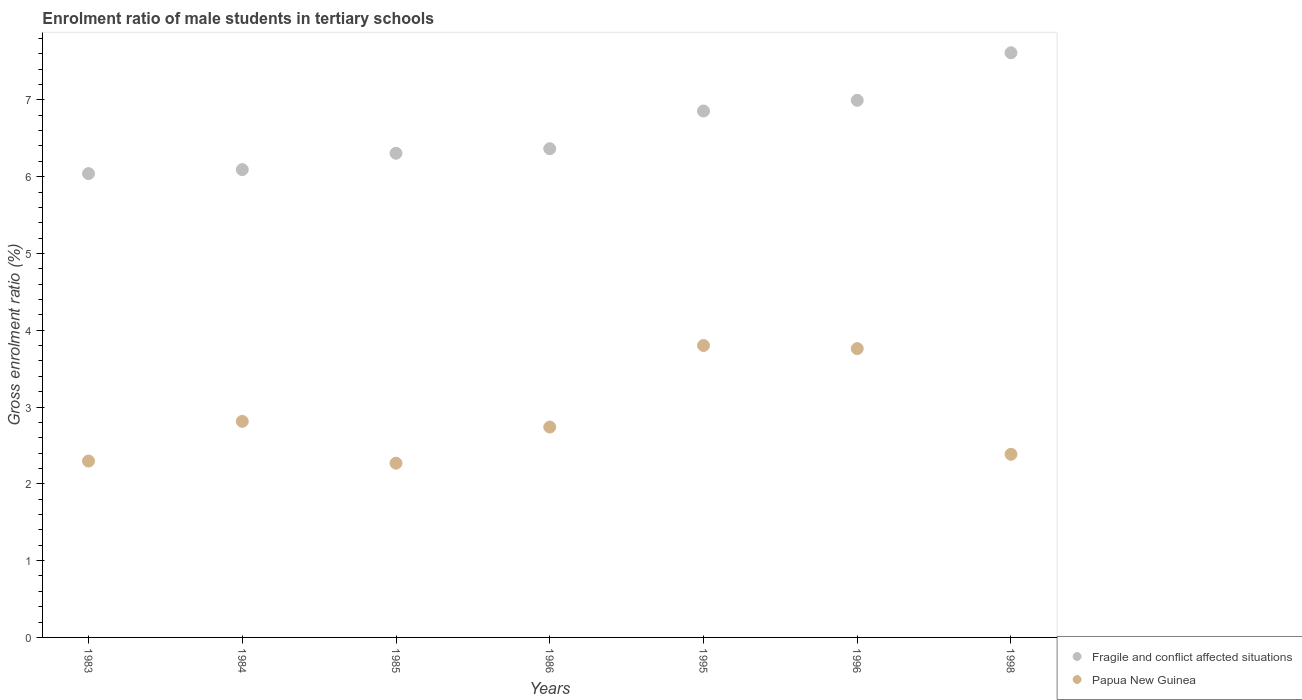How many different coloured dotlines are there?
Provide a succinct answer. 2. What is the enrolment ratio of male students in tertiary schools in Papua New Guinea in 1985?
Offer a very short reply. 2.27. Across all years, what is the maximum enrolment ratio of male students in tertiary schools in Papua New Guinea?
Keep it short and to the point. 3.8. Across all years, what is the minimum enrolment ratio of male students in tertiary schools in Papua New Guinea?
Your answer should be compact. 2.27. In which year was the enrolment ratio of male students in tertiary schools in Fragile and conflict affected situations maximum?
Ensure brevity in your answer.  1998. What is the total enrolment ratio of male students in tertiary schools in Papua New Guinea in the graph?
Make the answer very short. 20.07. What is the difference between the enrolment ratio of male students in tertiary schools in Papua New Guinea in 1983 and that in 1998?
Make the answer very short. -0.09. What is the difference between the enrolment ratio of male students in tertiary schools in Papua New Guinea in 1998 and the enrolment ratio of male students in tertiary schools in Fragile and conflict affected situations in 1986?
Offer a terse response. -3.98. What is the average enrolment ratio of male students in tertiary schools in Fragile and conflict affected situations per year?
Ensure brevity in your answer.  6.61. In the year 1998, what is the difference between the enrolment ratio of male students in tertiary schools in Fragile and conflict affected situations and enrolment ratio of male students in tertiary schools in Papua New Guinea?
Your answer should be very brief. 5.23. In how many years, is the enrolment ratio of male students in tertiary schools in Fragile and conflict affected situations greater than 6.8 %?
Your answer should be compact. 3. What is the ratio of the enrolment ratio of male students in tertiary schools in Papua New Guinea in 1983 to that in 1986?
Make the answer very short. 0.84. Is the enrolment ratio of male students in tertiary schools in Fragile and conflict affected situations in 1985 less than that in 1998?
Provide a short and direct response. Yes. What is the difference between the highest and the second highest enrolment ratio of male students in tertiary schools in Papua New Guinea?
Offer a very short reply. 0.04. What is the difference between the highest and the lowest enrolment ratio of male students in tertiary schools in Papua New Guinea?
Make the answer very short. 1.53. In how many years, is the enrolment ratio of male students in tertiary schools in Fragile and conflict affected situations greater than the average enrolment ratio of male students in tertiary schools in Fragile and conflict affected situations taken over all years?
Make the answer very short. 3. Is the sum of the enrolment ratio of male students in tertiary schools in Papua New Guinea in 1984 and 1995 greater than the maximum enrolment ratio of male students in tertiary schools in Fragile and conflict affected situations across all years?
Offer a very short reply. No. Is the enrolment ratio of male students in tertiary schools in Fragile and conflict affected situations strictly less than the enrolment ratio of male students in tertiary schools in Papua New Guinea over the years?
Keep it short and to the point. No. How many dotlines are there?
Your answer should be very brief. 2. How many years are there in the graph?
Make the answer very short. 7. What is the difference between two consecutive major ticks on the Y-axis?
Provide a short and direct response. 1. Are the values on the major ticks of Y-axis written in scientific E-notation?
Your answer should be compact. No. Does the graph contain grids?
Your response must be concise. No. Where does the legend appear in the graph?
Keep it short and to the point. Bottom right. What is the title of the graph?
Give a very brief answer. Enrolment ratio of male students in tertiary schools. What is the Gross enrolment ratio (%) of Fragile and conflict affected situations in 1983?
Provide a succinct answer. 6.04. What is the Gross enrolment ratio (%) of Papua New Guinea in 1983?
Offer a terse response. 2.3. What is the Gross enrolment ratio (%) of Fragile and conflict affected situations in 1984?
Offer a terse response. 6.09. What is the Gross enrolment ratio (%) in Papua New Guinea in 1984?
Provide a succinct answer. 2.81. What is the Gross enrolment ratio (%) in Fragile and conflict affected situations in 1985?
Ensure brevity in your answer.  6.31. What is the Gross enrolment ratio (%) in Papua New Guinea in 1985?
Your answer should be very brief. 2.27. What is the Gross enrolment ratio (%) in Fragile and conflict affected situations in 1986?
Provide a short and direct response. 6.36. What is the Gross enrolment ratio (%) of Papua New Guinea in 1986?
Your answer should be compact. 2.74. What is the Gross enrolment ratio (%) in Fragile and conflict affected situations in 1995?
Your answer should be very brief. 6.86. What is the Gross enrolment ratio (%) in Papua New Guinea in 1995?
Your response must be concise. 3.8. What is the Gross enrolment ratio (%) of Fragile and conflict affected situations in 1996?
Offer a terse response. 6.99. What is the Gross enrolment ratio (%) of Papua New Guinea in 1996?
Offer a terse response. 3.76. What is the Gross enrolment ratio (%) in Fragile and conflict affected situations in 1998?
Offer a very short reply. 7.61. What is the Gross enrolment ratio (%) in Papua New Guinea in 1998?
Offer a terse response. 2.38. Across all years, what is the maximum Gross enrolment ratio (%) of Fragile and conflict affected situations?
Provide a succinct answer. 7.61. Across all years, what is the maximum Gross enrolment ratio (%) in Papua New Guinea?
Offer a very short reply. 3.8. Across all years, what is the minimum Gross enrolment ratio (%) of Fragile and conflict affected situations?
Ensure brevity in your answer.  6.04. Across all years, what is the minimum Gross enrolment ratio (%) of Papua New Guinea?
Provide a succinct answer. 2.27. What is the total Gross enrolment ratio (%) of Fragile and conflict affected situations in the graph?
Provide a succinct answer. 46.26. What is the total Gross enrolment ratio (%) in Papua New Guinea in the graph?
Your answer should be very brief. 20.07. What is the difference between the Gross enrolment ratio (%) in Fragile and conflict affected situations in 1983 and that in 1984?
Make the answer very short. -0.05. What is the difference between the Gross enrolment ratio (%) of Papua New Guinea in 1983 and that in 1984?
Make the answer very short. -0.52. What is the difference between the Gross enrolment ratio (%) in Fragile and conflict affected situations in 1983 and that in 1985?
Offer a very short reply. -0.27. What is the difference between the Gross enrolment ratio (%) of Papua New Guinea in 1983 and that in 1985?
Make the answer very short. 0.03. What is the difference between the Gross enrolment ratio (%) in Fragile and conflict affected situations in 1983 and that in 1986?
Provide a succinct answer. -0.32. What is the difference between the Gross enrolment ratio (%) in Papua New Guinea in 1983 and that in 1986?
Your response must be concise. -0.44. What is the difference between the Gross enrolment ratio (%) in Fragile and conflict affected situations in 1983 and that in 1995?
Your answer should be compact. -0.82. What is the difference between the Gross enrolment ratio (%) in Papua New Guinea in 1983 and that in 1995?
Offer a terse response. -1.5. What is the difference between the Gross enrolment ratio (%) of Fragile and conflict affected situations in 1983 and that in 1996?
Your answer should be very brief. -0.95. What is the difference between the Gross enrolment ratio (%) in Papua New Guinea in 1983 and that in 1996?
Your response must be concise. -1.46. What is the difference between the Gross enrolment ratio (%) of Fragile and conflict affected situations in 1983 and that in 1998?
Ensure brevity in your answer.  -1.57. What is the difference between the Gross enrolment ratio (%) of Papua New Guinea in 1983 and that in 1998?
Provide a succinct answer. -0.09. What is the difference between the Gross enrolment ratio (%) in Fragile and conflict affected situations in 1984 and that in 1985?
Make the answer very short. -0.21. What is the difference between the Gross enrolment ratio (%) in Papua New Guinea in 1984 and that in 1985?
Provide a succinct answer. 0.54. What is the difference between the Gross enrolment ratio (%) of Fragile and conflict affected situations in 1984 and that in 1986?
Make the answer very short. -0.27. What is the difference between the Gross enrolment ratio (%) in Papua New Guinea in 1984 and that in 1986?
Give a very brief answer. 0.07. What is the difference between the Gross enrolment ratio (%) in Fragile and conflict affected situations in 1984 and that in 1995?
Ensure brevity in your answer.  -0.76. What is the difference between the Gross enrolment ratio (%) in Papua New Guinea in 1984 and that in 1995?
Your answer should be compact. -0.99. What is the difference between the Gross enrolment ratio (%) in Fragile and conflict affected situations in 1984 and that in 1996?
Keep it short and to the point. -0.9. What is the difference between the Gross enrolment ratio (%) in Papua New Guinea in 1984 and that in 1996?
Your answer should be very brief. -0.95. What is the difference between the Gross enrolment ratio (%) in Fragile and conflict affected situations in 1984 and that in 1998?
Keep it short and to the point. -1.52. What is the difference between the Gross enrolment ratio (%) in Papua New Guinea in 1984 and that in 1998?
Provide a short and direct response. 0.43. What is the difference between the Gross enrolment ratio (%) of Fragile and conflict affected situations in 1985 and that in 1986?
Provide a succinct answer. -0.06. What is the difference between the Gross enrolment ratio (%) in Papua New Guinea in 1985 and that in 1986?
Your answer should be very brief. -0.47. What is the difference between the Gross enrolment ratio (%) of Fragile and conflict affected situations in 1985 and that in 1995?
Your answer should be compact. -0.55. What is the difference between the Gross enrolment ratio (%) of Papua New Guinea in 1985 and that in 1995?
Provide a short and direct response. -1.53. What is the difference between the Gross enrolment ratio (%) of Fragile and conflict affected situations in 1985 and that in 1996?
Keep it short and to the point. -0.69. What is the difference between the Gross enrolment ratio (%) in Papua New Guinea in 1985 and that in 1996?
Provide a short and direct response. -1.49. What is the difference between the Gross enrolment ratio (%) of Fragile and conflict affected situations in 1985 and that in 1998?
Your answer should be very brief. -1.31. What is the difference between the Gross enrolment ratio (%) in Papua New Guinea in 1985 and that in 1998?
Keep it short and to the point. -0.12. What is the difference between the Gross enrolment ratio (%) in Fragile and conflict affected situations in 1986 and that in 1995?
Provide a short and direct response. -0.49. What is the difference between the Gross enrolment ratio (%) in Papua New Guinea in 1986 and that in 1995?
Your response must be concise. -1.06. What is the difference between the Gross enrolment ratio (%) of Fragile and conflict affected situations in 1986 and that in 1996?
Your answer should be very brief. -0.63. What is the difference between the Gross enrolment ratio (%) of Papua New Guinea in 1986 and that in 1996?
Make the answer very short. -1.02. What is the difference between the Gross enrolment ratio (%) in Fragile and conflict affected situations in 1986 and that in 1998?
Make the answer very short. -1.25. What is the difference between the Gross enrolment ratio (%) in Papua New Guinea in 1986 and that in 1998?
Give a very brief answer. 0.35. What is the difference between the Gross enrolment ratio (%) of Fragile and conflict affected situations in 1995 and that in 1996?
Your answer should be compact. -0.14. What is the difference between the Gross enrolment ratio (%) in Papua New Guinea in 1995 and that in 1996?
Your response must be concise. 0.04. What is the difference between the Gross enrolment ratio (%) in Fragile and conflict affected situations in 1995 and that in 1998?
Offer a very short reply. -0.76. What is the difference between the Gross enrolment ratio (%) of Papua New Guinea in 1995 and that in 1998?
Give a very brief answer. 1.42. What is the difference between the Gross enrolment ratio (%) of Fragile and conflict affected situations in 1996 and that in 1998?
Your response must be concise. -0.62. What is the difference between the Gross enrolment ratio (%) of Papua New Guinea in 1996 and that in 1998?
Your response must be concise. 1.38. What is the difference between the Gross enrolment ratio (%) in Fragile and conflict affected situations in 1983 and the Gross enrolment ratio (%) in Papua New Guinea in 1984?
Give a very brief answer. 3.23. What is the difference between the Gross enrolment ratio (%) in Fragile and conflict affected situations in 1983 and the Gross enrolment ratio (%) in Papua New Guinea in 1985?
Offer a very short reply. 3.77. What is the difference between the Gross enrolment ratio (%) in Fragile and conflict affected situations in 1983 and the Gross enrolment ratio (%) in Papua New Guinea in 1986?
Your response must be concise. 3.3. What is the difference between the Gross enrolment ratio (%) of Fragile and conflict affected situations in 1983 and the Gross enrolment ratio (%) of Papua New Guinea in 1995?
Your answer should be very brief. 2.24. What is the difference between the Gross enrolment ratio (%) of Fragile and conflict affected situations in 1983 and the Gross enrolment ratio (%) of Papua New Guinea in 1996?
Keep it short and to the point. 2.28. What is the difference between the Gross enrolment ratio (%) of Fragile and conflict affected situations in 1983 and the Gross enrolment ratio (%) of Papua New Guinea in 1998?
Your response must be concise. 3.65. What is the difference between the Gross enrolment ratio (%) of Fragile and conflict affected situations in 1984 and the Gross enrolment ratio (%) of Papua New Guinea in 1985?
Your response must be concise. 3.82. What is the difference between the Gross enrolment ratio (%) in Fragile and conflict affected situations in 1984 and the Gross enrolment ratio (%) in Papua New Guinea in 1986?
Your response must be concise. 3.35. What is the difference between the Gross enrolment ratio (%) in Fragile and conflict affected situations in 1984 and the Gross enrolment ratio (%) in Papua New Guinea in 1995?
Offer a very short reply. 2.29. What is the difference between the Gross enrolment ratio (%) of Fragile and conflict affected situations in 1984 and the Gross enrolment ratio (%) of Papua New Guinea in 1996?
Provide a short and direct response. 2.33. What is the difference between the Gross enrolment ratio (%) of Fragile and conflict affected situations in 1984 and the Gross enrolment ratio (%) of Papua New Guinea in 1998?
Offer a terse response. 3.71. What is the difference between the Gross enrolment ratio (%) of Fragile and conflict affected situations in 1985 and the Gross enrolment ratio (%) of Papua New Guinea in 1986?
Provide a succinct answer. 3.57. What is the difference between the Gross enrolment ratio (%) of Fragile and conflict affected situations in 1985 and the Gross enrolment ratio (%) of Papua New Guinea in 1995?
Make the answer very short. 2.5. What is the difference between the Gross enrolment ratio (%) of Fragile and conflict affected situations in 1985 and the Gross enrolment ratio (%) of Papua New Guinea in 1996?
Offer a terse response. 2.54. What is the difference between the Gross enrolment ratio (%) in Fragile and conflict affected situations in 1985 and the Gross enrolment ratio (%) in Papua New Guinea in 1998?
Give a very brief answer. 3.92. What is the difference between the Gross enrolment ratio (%) in Fragile and conflict affected situations in 1986 and the Gross enrolment ratio (%) in Papua New Guinea in 1995?
Your response must be concise. 2.56. What is the difference between the Gross enrolment ratio (%) of Fragile and conflict affected situations in 1986 and the Gross enrolment ratio (%) of Papua New Guinea in 1996?
Your answer should be compact. 2.6. What is the difference between the Gross enrolment ratio (%) of Fragile and conflict affected situations in 1986 and the Gross enrolment ratio (%) of Papua New Guinea in 1998?
Give a very brief answer. 3.98. What is the difference between the Gross enrolment ratio (%) in Fragile and conflict affected situations in 1995 and the Gross enrolment ratio (%) in Papua New Guinea in 1996?
Your response must be concise. 3.09. What is the difference between the Gross enrolment ratio (%) of Fragile and conflict affected situations in 1995 and the Gross enrolment ratio (%) of Papua New Guinea in 1998?
Keep it short and to the point. 4.47. What is the difference between the Gross enrolment ratio (%) in Fragile and conflict affected situations in 1996 and the Gross enrolment ratio (%) in Papua New Guinea in 1998?
Offer a terse response. 4.61. What is the average Gross enrolment ratio (%) in Fragile and conflict affected situations per year?
Give a very brief answer. 6.61. What is the average Gross enrolment ratio (%) in Papua New Guinea per year?
Your response must be concise. 2.87. In the year 1983, what is the difference between the Gross enrolment ratio (%) in Fragile and conflict affected situations and Gross enrolment ratio (%) in Papua New Guinea?
Your answer should be very brief. 3.74. In the year 1984, what is the difference between the Gross enrolment ratio (%) in Fragile and conflict affected situations and Gross enrolment ratio (%) in Papua New Guinea?
Your response must be concise. 3.28. In the year 1985, what is the difference between the Gross enrolment ratio (%) of Fragile and conflict affected situations and Gross enrolment ratio (%) of Papua New Guinea?
Your answer should be very brief. 4.04. In the year 1986, what is the difference between the Gross enrolment ratio (%) in Fragile and conflict affected situations and Gross enrolment ratio (%) in Papua New Guinea?
Provide a succinct answer. 3.62. In the year 1995, what is the difference between the Gross enrolment ratio (%) in Fragile and conflict affected situations and Gross enrolment ratio (%) in Papua New Guinea?
Offer a terse response. 3.05. In the year 1996, what is the difference between the Gross enrolment ratio (%) in Fragile and conflict affected situations and Gross enrolment ratio (%) in Papua New Guinea?
Keep it short and to the point. 3.23. In the year 1998, what is the difference between the Gross enrolment ratio (%) in Fragile and conflict affected situations and Gross enrolment ratio (%) in Papua New Guinea?
Your answer should be very brief. 5.23. What is the ratio of the Gross enrolment ratio (%) in Fragile and conflict affected situations in 1983 to that in 1984?
Your answer should be very brief. 0.99. What is the ratio of the Gross enrolment ratio (%) of Papua New Guinea in 1983 to that in 1984?
Your response must be concise. 0.82. What is the ratio of the Gross enrolment ratio (%) of Fragile and conflict affected situations in 1983 to that in 1985?
Keep it short and to the point. 0.96. What is the ratio of the Gross enrolment ratio (%) in Papua New Guinea in 1983 to that in 1985?
Make the answer very short. 1.01. What is the ratio of the Gross enrolment ratio (%) in Fragile and conflict affected situations in 1983 to that in 1986?
Your answer should be compact. 0.95. What is the ratio of the Gross enrolment ratio (%) of Papua New Guinea in 1983 to that in 1986?
Provide a succinct answer. 0.84. What is the ratio of the Gross enrolment ratio (%) in Fragile and conflict affected situations in 1983 to that in 1995?
Offer a very short reply. 0.88. What is the ratio of the Gross enrolment ratio (%) in Papua New Guinea in 1983 to that in 1995?
Offer a terse response. 0.6. What is the ratio of the Gross enrolment ratio (%) of Fragile and conflict affected situations in 1983 to that in 1996?
Your response must be concise. 0.86. What is the ratio of the Gross enrolment ratio (%) in Papua New Guinea in 1983 to that in 1996?
Your answer should be compact. 0.61. What is the ratio of the Gross enrolment ratio (%) of Fragile and conflict affected situations in 1983 to that in 1998?
Provide a succinct answer. 0.79. What is the ratio of the Gross enrolment ratio (%) in Papua New Guinea in 1983 to that in 1998?
Make the answer very short. 0.96. What is the ratio of the Gross enrolment ratio (%) in Fragile and conflict affected situations in 1984 to that in 1985?
Offer a terse response. 0.97. What is the ratio of the Gross enrolment ratio (%) of Papua New Guinea in 1984 to that in 1985?
Ensure brevity in your answer.  1.24. What is the ratio of the Gross enrolment ratio (%) of Fragile and conflict affected situations in 1984 to that in 1986?
Your answer should be compact. 0.96. What is the ratio of the Gross enrolment ratio (%) of Papua New Guinea in 1984 to that in 1986?
Your answer should be very brief. 1.03. What is the ratio of the Gross enrolment ratio (%) of Fragile and conflict affected situations in 1984 to that in 1995?
Provide a succinct answer. 0.89. What is the ratio of the Gross enrolment ratio (%) of Papua New Guinea in 1984 to that in 1995?
Your response must be concise. 0.74. What is the ratio of the Gross enrolment ratio (%) in Fragile and conflict affected situations in 1984 to that in 1996?
Give a very brief answer. 0.87. What is the ratio of the Gross enrolment ratio (%) of Papua New Guinea in 1984 to that in 1996?
Offer a terse response. 0.75. What is the ratio of the Gross enrolment ratio (%) of Fragile and conflict affected situations in 1984 to that in 1998?
Your response must be concise. 0.8. What is the ratio of the Gross enrolment ratio (%) in Papua New Guinea in 1984 to that in 1998?
Your answer should be compact. 1.18. What is the ratio of the Gross enrolment ratio (%) in Papua New Guinea in 1985 to that in 1986?
Make the answer very short. 0.83. What is the ratio of the Gross enrolment ratio (%) of Fragile and conflict affected situations in 1985 to that in 1995?
Ensure brevity in your answer.  0.92. What is the ratio of the Gross enrolment ratio (%) in Papua New Guinea in 1985 to that in 1995?
Your response must be concise. 0.6. What is the ratio of the Gross enrolment ratio (%) of Fragile and conflict affected situations in 1985 to that in 1996?
Give a very brief answer. 0.9. What is the ratio of the Gross enrolment ratio (%) of Papua New Guinea in 1985 to that in 1996?
Make the answer very short. 0.6. What is the ratio of the Gross enrolment ratio (%) in Fragile and conflict affected situations in 1985 to that in 1998?
Your response must be concise. 0.83. What is the ratio of the Gross enrolment ratio (%) of Papua New Guinea in 1985 to that in 1998?
Your answer should be compact. 0.95. What is the ratio of the Gross enrolment ratio (%) of Fragile and conflict affected situations in 1986 to that in 1995?
Offer a very short reply. 0.93. What is the ratio of the Gross enrolment ratio (%) of Papua New Guinea in 1986 to that in 1995?
Offer a terse response. 0.72. What is the ratio of the Gross enrolment ratio (%) of Fragile and conflict affected situations in 1986 to that in 1996?
Provide a short and direct response. 0.91. What is the ratio of the Gross enrolment ratio (%) in Papua New Guinea in 1986 to that in 1996?
Give a very brief answer. 0.73. What is the ratio of the Gross enrolment ratio (%) in Fragile and conflict affected situations in 1986 to that in 1998?
Your answer should be compact. 0.84. What is the ratio of the Gross enrolment ratio (%) of Papua New Guinea in 1986 to that in 1998?
Provide a succinct answer. 1.15. What is the ratio of the Gross enrolment ratio (%) in Fragile and conflict affected situations in 1995 to that in 1996?
Keep it short and to the point. 0.98. What is the ratio of the Gross enrolment ratio (%) of Papua New Guinea in 1995 to that in 1996?
Your answer should be compact. 1.01. What is the ratio of the Gross enrolment ratio (%) in Fragile and conflict affected situations in 1995 to that in 1998?
Keep it short and to the point. 0.9. What is the ratio of the Gross enrolment ratio (%) in Papua New Guinea in 1995 to that in 1998?
Offer a terse response. 1.59. What is the ratio of the Gross enrolment ratio (%) of Fragile and conflict affected situations in 1996 to that in 1998?
Give a very brief answer. 0.92. What is the ratio of the Gross enrolment ratio (%) of Papua New Guinea in 1996 to that in 1998?
Make the answer very short. 1.58. What is the difference between the highest and the second highest Gross enrolment ratio (%) in Fragile and conflict affected situations?
Give a very brief answer. 0.62. What is the difference between the highest and the second highest Gross enrolment ratio (%) in Papua New Guinea?
Your answer should be very brief. 0.04. What is the difference between the highest and the lowest Gross enrolment ratio (%) of Fragile and conflict affected situations?
Offer a terse response. 1.57. What is the difference between the highest and the lowest Gross enrolment ratio (%) of Papua New Guinea?
Your answer should be very brief. 1.53. 